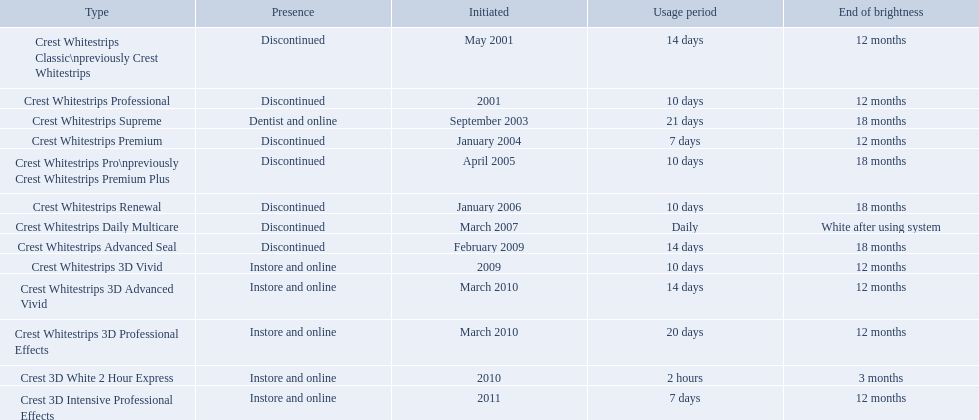What types of crest whitestrips have been released? Crest Whitestrips Classic\npreviously Crest Whitestrips, Crest Whitestrips Professional, Crest Whitestrips Supreme, Crest Whitestrips Premium, Crest Whitestrips Pro\npreviously Crest Whitestrips Premium Plus, Crest Whitestrips Renewal, Crest Whitestrips Daily Multicare, Crest Whitestrips Advanced Seal, Crest Whitestrips 3D Vivid, Crest Whitestrips 3D Advanced Vivid, Crest Whitestrips 3D Professional Effects, Crest 3D White 2 Hour Express, Crest 3D Intensive Professional Effects. What was the length of use for each type? 14 days, 10 days, 21 days, 7 days, 10 days, 10 days, Daily, 14 days, 10 days, 14 days, 20 days, 2 hours, 7 days. And how long did each last? 12 months, 12 months, 18 months, 12 months, 18 months, 18 months, White after using system, 18 months, 12 months, 12 months, 12 months, 3 months, 12 months. Of those models, which lasted the longest with the longest length of use? Crest Whitestrips Supreme. What are all of the model names? Crest Whitestrips Classic\npreviously Crest Whitestrips, Crest Whitestrips Professional, Crest Whitestrips Supreme, Crest Whitestrips Premium, Crest Whitestrips Pro\npreviously Crest Whitestrips Premium Plus, Crest Whitestrips Renewal, Crest Whitestrips Daily Multicare, Crest Whitestrips Advanced Seal, Crest Whitestrips 3D Vivid, Crest Whitestrips 3D Advanced Vivid, Crest Whitestrips 3D Professional Effects, Crest 3D White 2 Hour Express, Crest 3D Intensive Professional Effects. When were they first introduced? May 2001, 2001, September 2003, January 2004, April 2005, January 2006, March 2007, February 2009, 2009, March 2010, March 2010, 2010, 2011. Along with crest whitestrips 3d advanced vivid, which other model was introduced in march 2010? Crest Whitestrips 3D Professional Effects. What products are listed? Crest Whitestrips Classic\npreviously Crest Whitestrips, Crest Whitestrips Professional, Crest Whitestrips Supreme, Crest Whitestrips Premium, Crest Whitestrips Pro\npreviously Crest Whitestrips Premium Plus, Crest Whitestrips Renewal, Crest Whitestrips Daily Multicare, Crest Whitestrips Advanced Seal, Crest Whitestrips 3D Vivid, Crest Whitestrips 3D Advanced Vivid, Crest Whitestrips 3D Professional Effects, Crest 3D White 2 Hour Express, Crest 3D Intensive Professional Effects. Of these, which was were introduced in march, 2010? Crest Whitestrips 3D Advanced Vivid, Crest Whitestrips 3D Professional Effects. Of these, which were not 3d advanced vivid? Crest Whitestrips 3D Professional Effects. What were the models of crest whitestrips? Crest Whitestrips Classic\npreviously Crest Whitestrips, Crest Whitestrips Professional, Crest Whitestrips Supreme, Crest Whitestrips Premium, Crest Whitestrips Pro\npreviously Crest Whitestrips Premium Plus, Crest Whitestrips Renewal, Crest Whitestrips Daily Multicare, Crest Whitestrips Advanced Seal, Crest Whitestrips 3D Vivid, Crest Whitestrips 3D Advanced Vivid, Crest Whitestrips 3D Professional Effects, Crest 3D White 2 Hour Express, Crest 3D Intensive Professional Effects. When were they introduced? May 2001, 2001, September 2003, January 2004, April 2005, January 2006, March 2007, February 2009, 2009, March 2010, March 2010, 2010, 2011. And what is their availability? Discontinued, Discontinued, Dentist and online, Discontinued, Discontinued, Discontinued, Discontinued, Discontinued, Instore and online, Instore and online, Instore and online, Instore and online, Instore and online. Along crest whitestrips 3d vivid, which discontinued model was released in 2009? Crest Whitestrips Advanced Seal. 